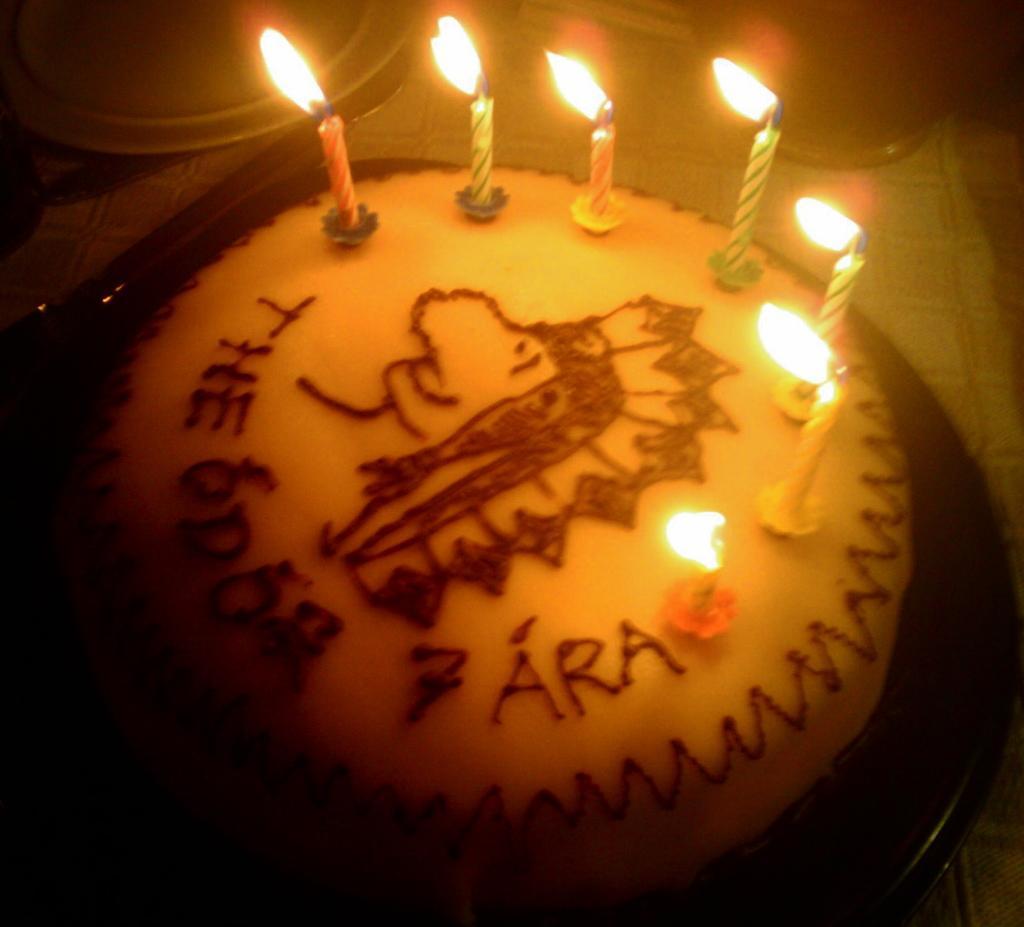How would you summarize this image in a sentence or two? In this image there is a cake, there are candles, there is a knife, there is a table, there are objects truncated towards the top of the image. 